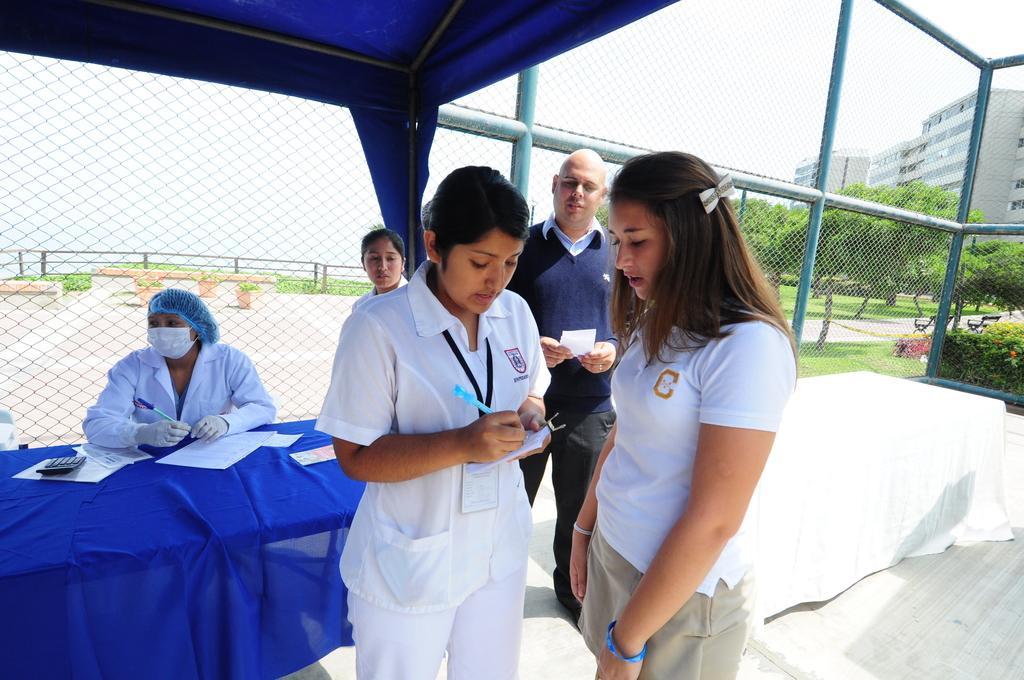Please provide a concise description of this image. In this picture we can see there are four people standing and a person is sitting. In front of the person there is a table, covered with a cloth and on the table there are papers and a calculator. A woman in the white dress is holding a paper and writing something on the paper. Behind the people there is the fence, benches, pots, trees, buildings and the sky and other things. 